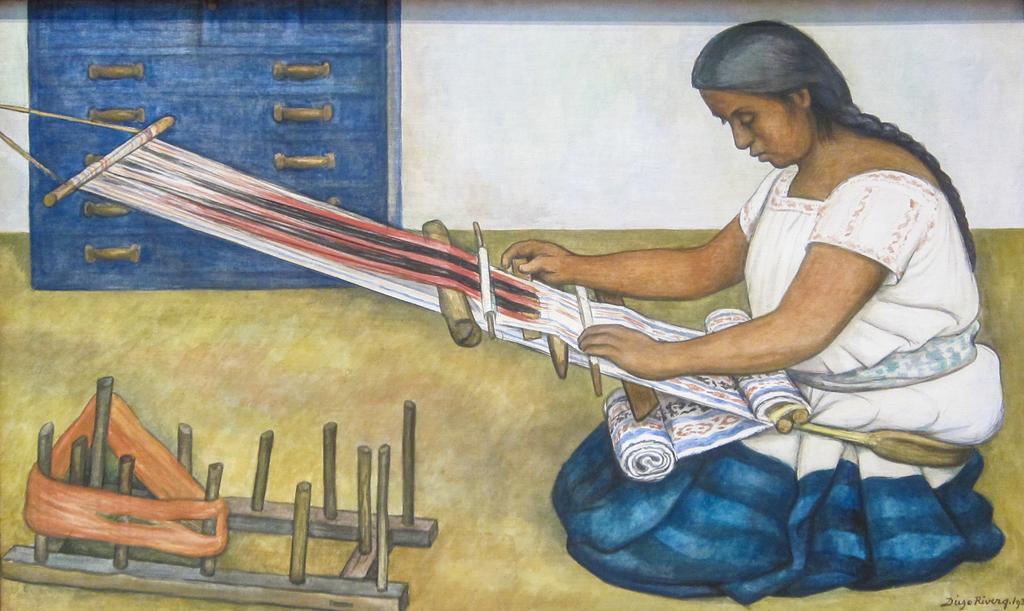In one or two sentences, can you explain what this image depicts? In this picture we can see a painting of a person and we can see the painting of the cloth and many other objects. In the background we can see the wall and a blue color object seems to be placed on the ground. 